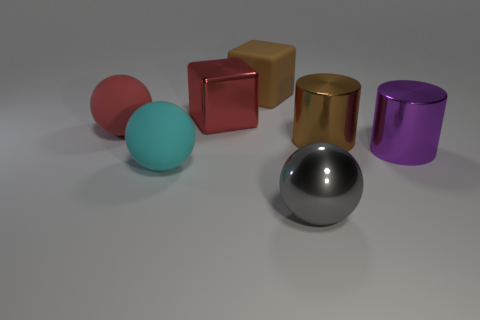Subtract all big metal spheres. How many spheres are left? 2 Subtract all gray balls. How many balls are left? 2 Subtract 1 balls. How many balls are left? 2 Add 1 small blue metal objects. How many objects exist? 8 Subtract all brown balls. Subtract all brown blocks. How many balls are left? 3 Subtract all tiny green metal things. Subtract all large red matte balls. How many objects are left? 6 Add 2 big cylinders. How many big cylinders are left? 4 Add 6 spheres. How many spheres exist? 9 Subtract 0 cyan blocks. How many objects are left? 7 Subtract all cylinders. How many objects are left? 5 